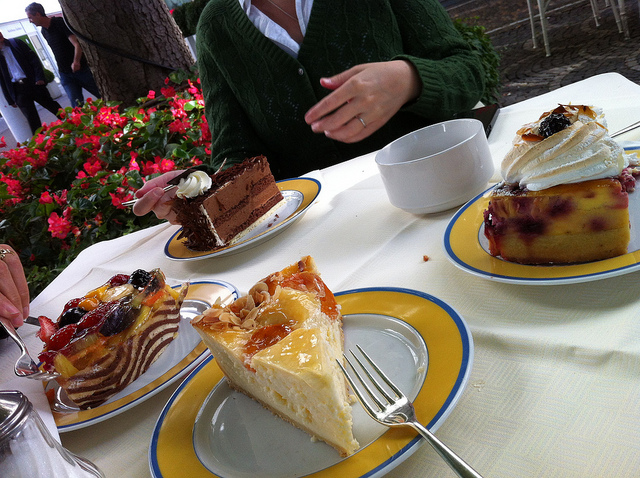How many skiiers are standing to the right of the train car? I apologize for the confusion, but it seems there was a mistake. There are no skiiers in the image to count. Instead, the image actually displays a selection of delicious cakes on plates set on a table in an outdoor setting. Is there anything else you'd like to know about the image? 